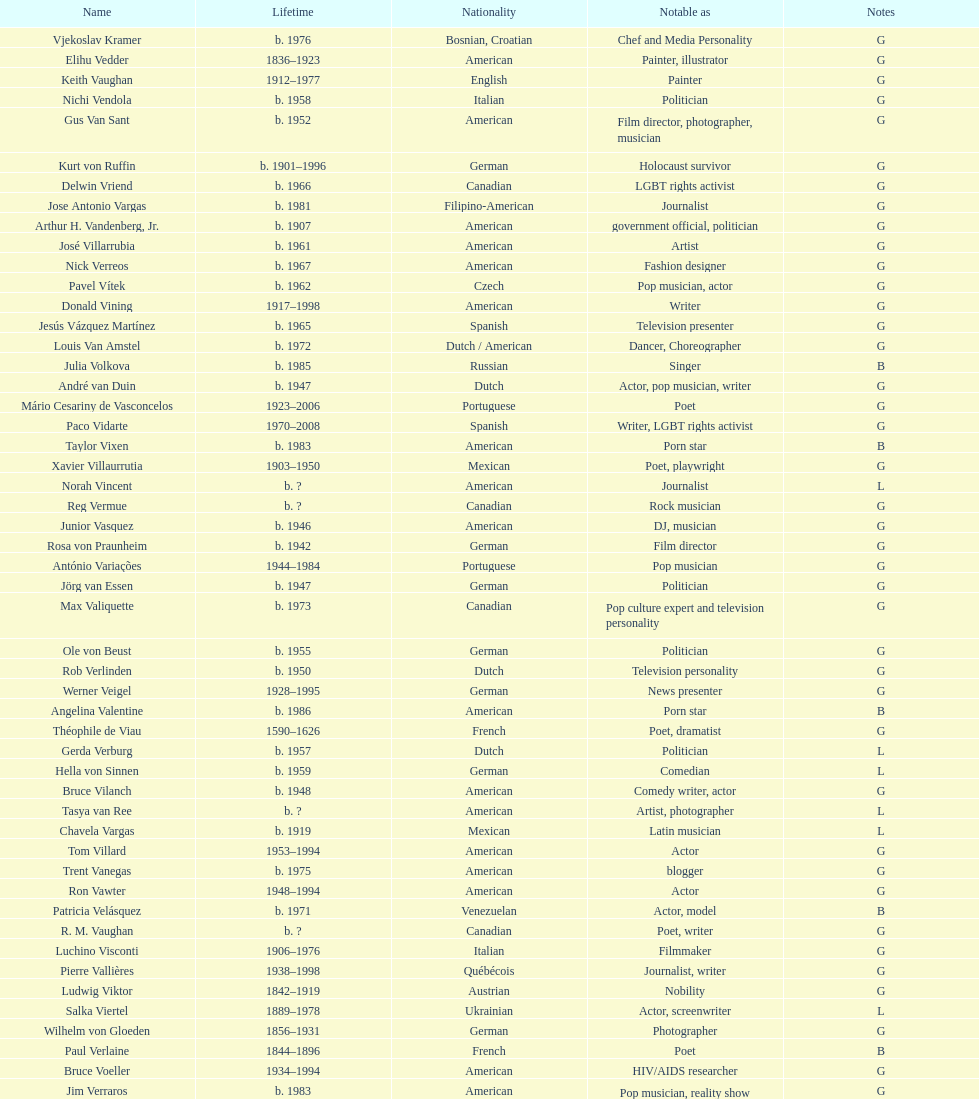What is the number of individuals in this group who were indian? 1. 